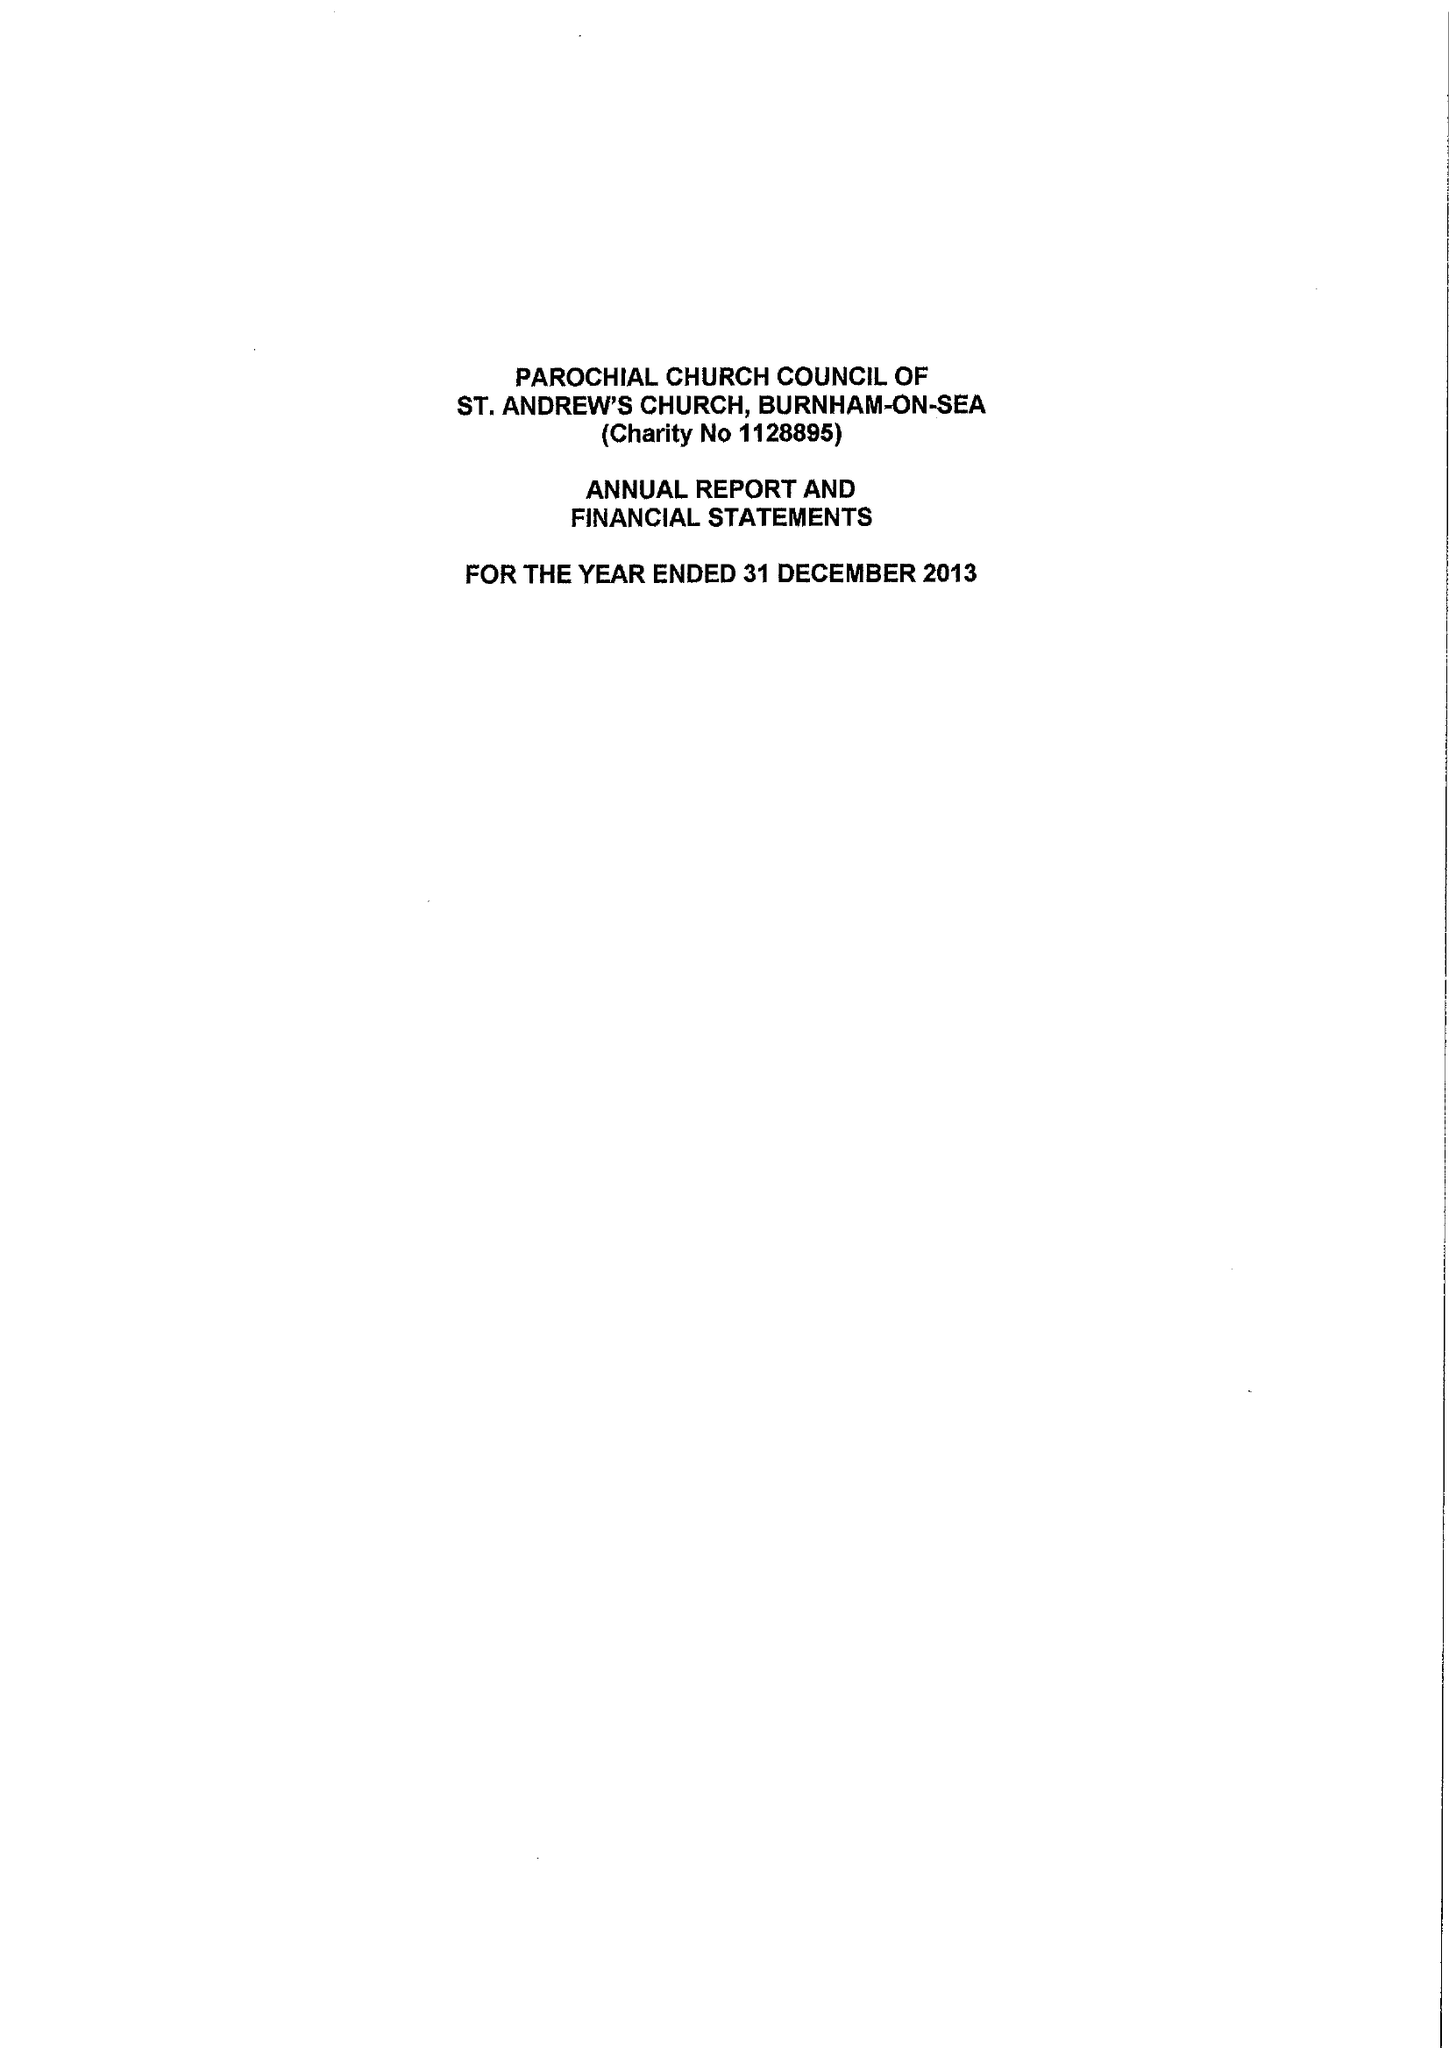What is the value for the charity_number?
Answer the question using a single word or phrase. 1128895 